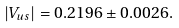Convert formula to latex. <formula><loc_0><loc_0><loc_500><loc_500>| V _ { u s } | = 0 . 2 1 9 6 \pm 0 . 0 0 2 6 .</formula> 